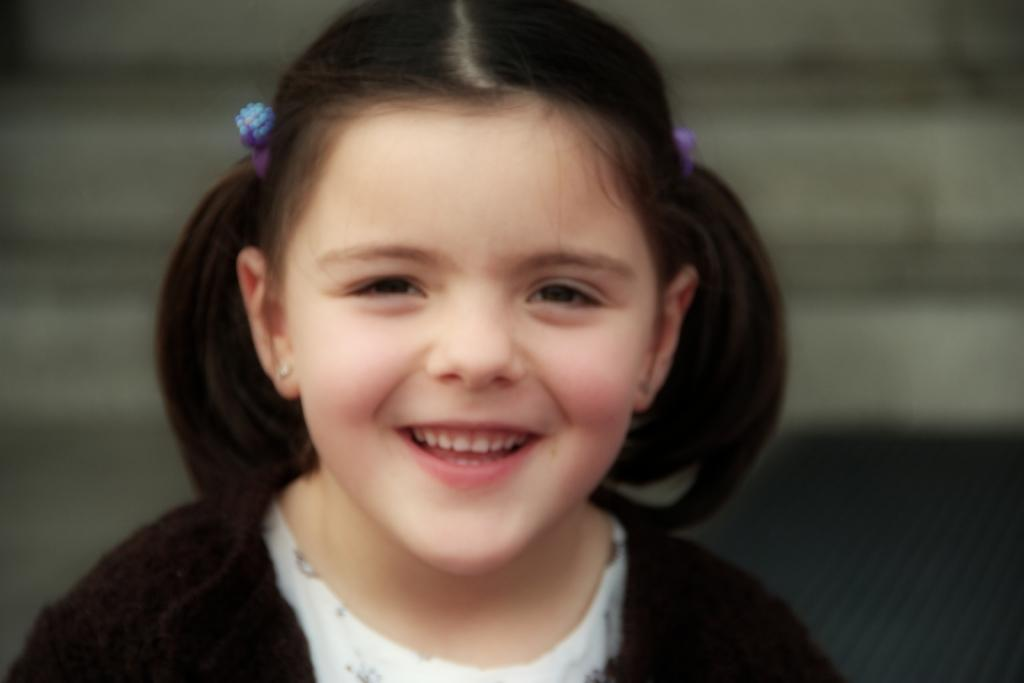Who is the main subject in the picture? There is a girl in the picture. What is the girl doing in the image? The girl is smiling. Can you describe the background of the image? The background of the image is blurry. What type of shoes is the girl reading in the image? There is no mention of shoes or reading in the image; it only features a girl smiling with a blurry background. 